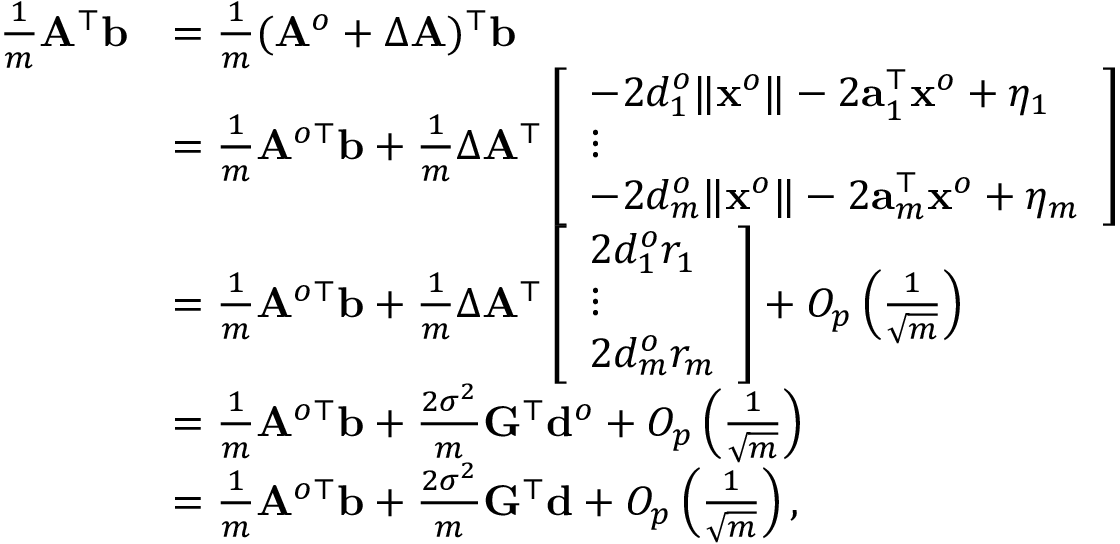<formula> <loc_0><loc_0><loc_500><loc_500>\begin{array} { r l } { \frac { 1 } { m } { A } ^ { \top } { b } } & { = \frac { 1 } { m } ( { A } ^ { o } + \Delta { A } ) ^ { \top } { b } } \\ & { = \frac { 1 } { m } { A } ^ { o \top } { b } + \frac { 1 } { m } \Delta { A } ^ { \top } \left [ \begin{array} { l } { - 2 d _ { 1 } ^ { o } \| { x } ^ { o } \| - 2 { a } _ { 1 } ^ { \top } { x } ^ { o } + \eta _ { 1 } } \\ { \vdots } \\ { - 2 d _ { m } ^ { o } \| { x } ^ { o } \| - 2 { a } _ { m } ^ { \top } { x } ^ { o } + \eta _ { m } } \end{array} \right ] } \\ & { = \frac { 1 } { m } { A } ^ { o \top } { b } + \frac { 1 } { m } \Delta { A } ^ { \top } \left [ \begin{array} { l } { 2 d _ { 1 } ^ { o } r _ { 1 } } \\ { \vdots } \\ { 2 d _ { m } ^ { o } r _ { m } } \end{array} \right ] + O _ { p } \left ( \frac { 1 } { \sqrt { m } } \right ) } \\ & { = \frac { 1 } { m } { A } ^ { o \top } { b } + \frac { 2 \sigma ^ { 2 } } { m } { G } ^ { \top } { d } ^ { o } + O _ { p } \left ( \frac { 1 } { \sqrt { m } } \right ) } \\ & { = \frac { 1 } { m } { A } ^ { o \top } { b } + \frac { 2 \sigma ^ { 2 } } { m } { G } ^ { \top } { d } + O _ { p } \left ( \frac { 1 } { \sqrt { m } } \right ) , } \end{array}</formula> 